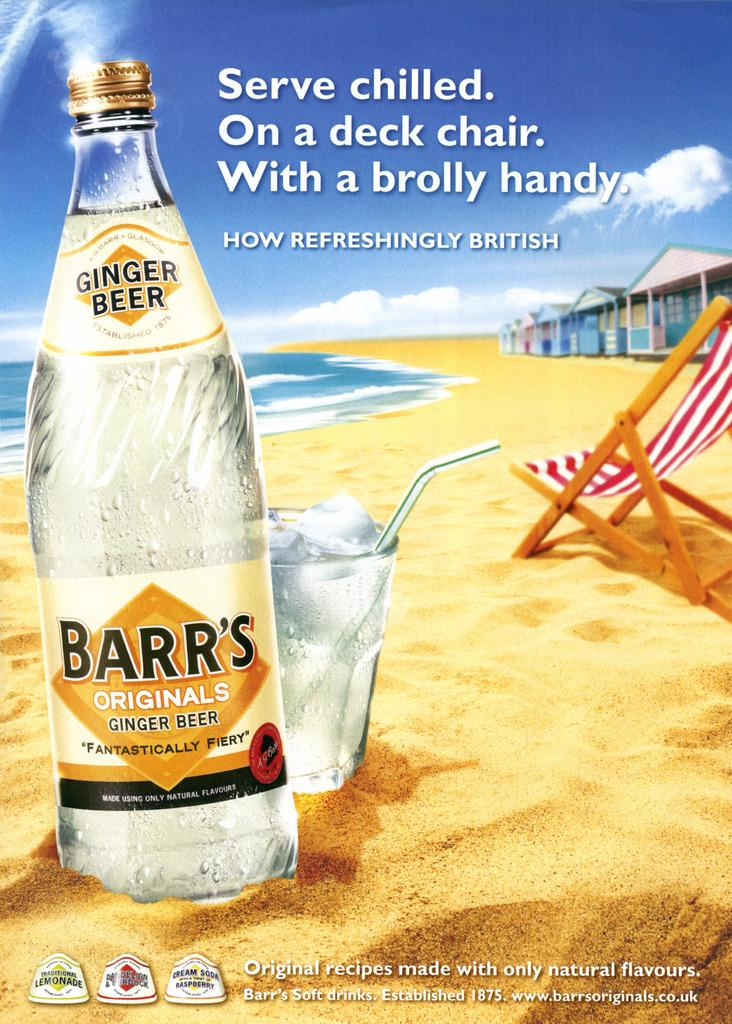<image>
Render a clear and concise summary of the photo. An advertisement displays a bottle for Barr's Originals Ginger Ale. 